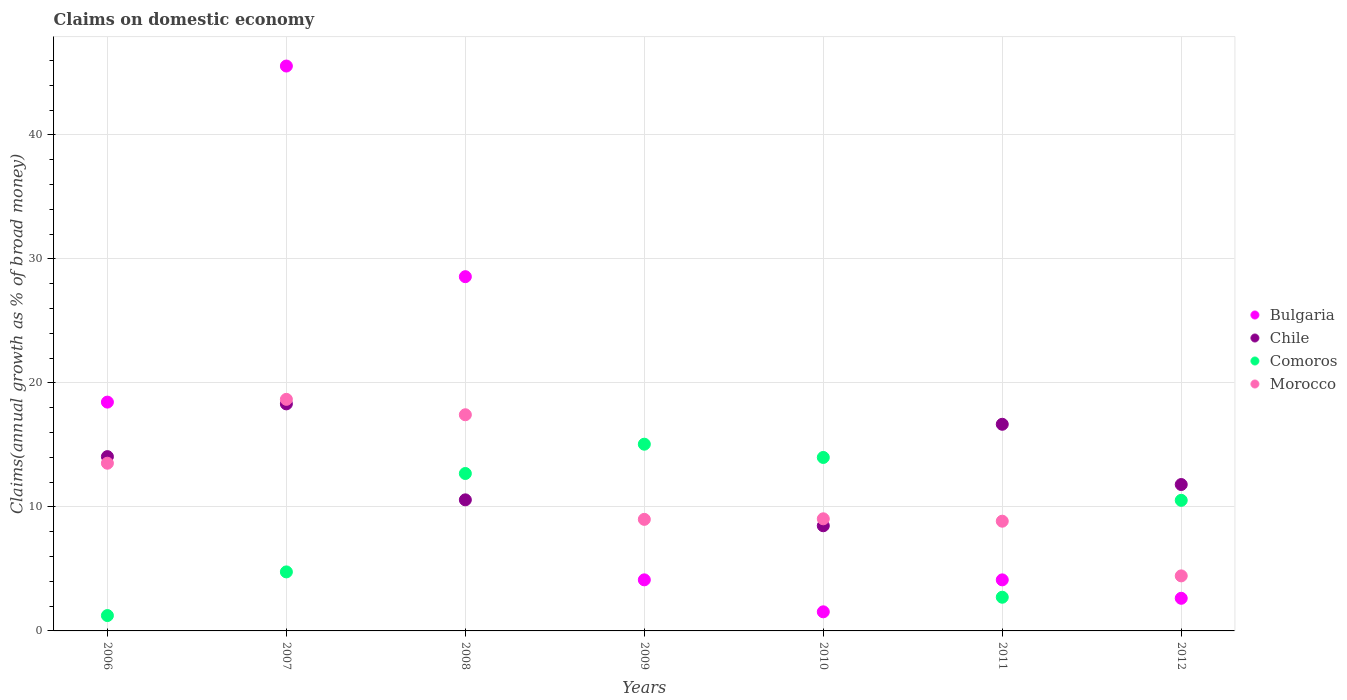How many different coloured dotlines are there?
Offer a very short reply. 4. What is the percentage of broad money claimed on domestic economy in Chile in 2009?
Ensure brevity in your answer.  0. Across all years, what is the maximum percentage of broad money claimed on domestic economy in Chile?
Keep it short and to the point. 18.31. Across all years, what is the minimum percentage of broad money claimed on domestic economy in Morocco?
Give a very brief answer. 4.44. In which year was the percentage of broad money claimed on domestic economy in Comoros maximum?
Your response must be concise. 2009. What is the total percentage of broad money claimed on domestic economy in Comoros in the graph?
Provide a succinct answer. 61. What is the difference between the percentage of broad money claimed on domestic economy in Morocco in 2007 and that in 2012?
Give a very brief answer. 14.24. What is the difference between the percentage of broad money claimed on domestic economy in Bulgaria in 2011 and the percentage of broad money claimed on domestic economy in Morocco in 2007?
Provide a short and direct response. -14.56. What is the average percentage of broad money claimed on domestic economy in Comoros per year?
Ensure brevity in your answer.  8.71. In the year 2006, what is the difference between the percentage of broad money claimed on domestic economy in Morocco and percentage of broad money claimed on domestic economy in Comoros?
Keep it short and to the point. 12.29. In how many years, is the percentage of broad money claimed on domestic economy in Chile greater than 14 %?
Provide a short and direct response. 3. What is the ratio of the percentage of broad money claimed on domestic economy in Bulgaria in 2009 to that in 2012?
Ensure brevity in your answer.  1.57. Is the percentage of broad money claimed on domestic economy in Bulgaria in 2009 less than that in 2012?
Offer a very short reply. No. What is the difference between the highest and the second highest percentage of broad money claimed on domestic economy in Bulgaria?
Provide a succinct answer. 16.99. What is the difference between the highest and the lowest percentage of broad money claimed on domestic economy in Morocco?
Provide a short and direct response. 14.24. In how many years, is the percentage of broad money claimed on domestic economy in Chile greater than the average percentage of broad money claimed on domestic economy in Chile taken over all years?
Your response must be concise. 4. Is it the case that in every year, the sum of the percentage of broad money claimed on domestic economy in Bulgaria and percentage of broad money claimed on domestic economy in Morocco  is greater than the percentage of broad money claimed on domestic economy in Comoros?
Ensure brevity in your answer.  No. Is the percentage of broad money claimed on domestic economy in Chile strictly greater than the percentage of broad money claimed on domestic economy in Comoros over the years?
Offer a very short reply. No. Is the percentage of broad money claimed on domestic economy in Comoros strictly less than the percentage of broad money claimed on domestic economy in Bulgaria over the years?
Your response must be concise. No. How many dotlines are there?
Your answer should be compact. 4. How many years are there in the graph?
Offer a terse response. 7. What is the difference between two consecutive major ticks on the Y-axis?
Keep it short and to the point. 10. Are the values on the major ticks of Y-axis written in scientific E-notation?
Provide a succinct answer. No. Where does the legend appear in the graph?
Keep it short and to the point. Center right. How are the legend labels stacked?
Your answer should be compact. Vertical. What is the title of the graph?
Give a very brief answer. Claims on domestic economy. Does "Madagascar" appear as one of the legend labels in the graph?
Offer a terse response. No. What is the label or title of the Y-axis?
Offer a terse response. Claims(annual growth as % of broad money). What is the Claims(annual growth as % of broad money) in Bulgaria in 2006?
Your answer should be very brief. 18.45. What is the Claims(annual growth as % of broad money) in Chile in 2006?
Provide a short and direct response. 14.06. What is the Claims(annual growth as % of broad money) of Comoros in 2006?
Your answer should be compact. 1.24. What is the Claims(annual growth as % of broad money) of Morocco in 2006?
Ensure brevity in your answer.  13.53. What is the Claims(annual growth as % of broad money) in Bulgaria in 2007?
Provide a succinct answer. 45.56. What is the Claims(annual growth as % of broad money) in Chile in 2007?
Ensure brevity in your answer.  18.31. What is the Claims(annual growth as % of broad money) of Comoros in 2007?
Keep it short and to the point. 4.76. What is the Claims(annual growth as % of broad money) in Morocco in 2007?
Offer a terse response. 18.68. What is the Claims(annual growth as % of broad money) in Bulgaria in 2008?
Give a very brief answer. 28.57. What is the Claims(annual growth as % of broad money) of Chile in 2008?
Offer a terse response. 10.57. What is the Claims(annual growth as % of broad money) in Comoros in 2008?
Give a very brief answer. 12.7. What is the Claims(annual growth as % of broad money) in Morocco in 2008?
Your response must be concise. 17.43. What is the Claims(annual growth as % of broad money) in Bulgaria in 2009?
Ensure brevity in your answer.  4.12. What is the Claims(annual growth as % of broad money) of Chile in 2009?
Make the answer very short. 0. What is the Claims(annual growth as % of broad money) of Comoros in 2009?
Your response must be concise. 15.06. What is the Claims(annual growth as % of broad money) of Morocco in 2009?
Make the answer very short. 9. What is the Claims(annual growth as % of broad money) of Bulgaria in 2010?
Give a very brief answer. 1.54. What is the Claims(annual growth as % of broad money) of Chile in 2010?
Keep it short and to the point. 8.48. What is the Claims(annual growth as % of broad money) in Comoros in 2010?
Ensure brevity in your answer.  13.99. What is the Claims(annual growth as % of broad money) in Morocco in 2010?
Give a very brief answer. 9.04. What is the Claims(annual growth as % of broad money) in Bulgaria in 2011?
Provide a short and direct response. 4.12. What is the Claims(annual growth as % of broad money) of Chile in 2011?
Make the answer very short. 16.67. What is the Claims(annual growth as % of broad money) in Comoros in 2011?
Keep it short and to the point. 2.72. What is the Claims(annual growth as % of broad money) in Morocco in 2011?
Provide a short and direct response. 8.85. What is the Claims(annual growth as % of broad money) in Bulgaria in 2012?
Your answer should be compact. 2.63. What is the Claims(annual growth as % of broad money) of Chile in 2012?
Provide a succinct answer. 11.81. What is the Claims(annual growth as % of broad money) in Comoros in 2012?
Offer a very short reply. 10.53. What is the Claims(annual growth as % of broad money) in Morocco in 2012?
Your answer should be very brief. 4.44. Across all years, what is the maximum Claims(annual growth as % of broad money) of Bulgaria?
Your answer should be very brief. 45.56. Across all years, what is the maximum Claims(annual growth as % of broad money) in Chile?
Provide a short and direct response. 18.31. Across all years, what is the maximum Claims(annual growth as % of broad money) of Comoros?
Your answer should be compact. 15.06. Across all years, what is the maximum Claims(annual growth as % of broad money) of Morocco?
Your answer should be compact. 18.68. Across all years, what is the minimum Claims(annual growth as % of broad money) of Bulgaria?
Ensure brevity in your answer.  1.54. Across all years, what is the minimum Claims(annual growth as % of broad money) of Chile?
Your answer should be very brief. 0. Across all years, what is the minimum Claims(annual growth as % of broad money) of Comoros?
Make the answer very short. 1.24. Across all years, what is the minimum Claims(annual growth as % of broad money) in Morocco?
Give a very brief answer. 4.44. What is the total Claims(annual growth as % of broad money) of Bulgaria in the graph?
Offer a very short reply. 104.99. What is the total Claims(annual growth as % of broad money) of Chile in the graph?
Ensure brevity in your answer.  79.9. What is the total Claims(annual growth as % of broad money) in Comoros in the graph?
Make the answer very short. 61. What is the total Claims(annual growth as % of broad money) in Morocco in the graph?
Offer a terse response. 80.97. What is the difference between the Claims(annual growth as % of broad money) in Bulgaria in 2006 and that in 2007?
Your response must be concise. -27.11. What is the difference between the Claims(annual growth as % of broad money) in Chile in 2006 and that in 2007?
Provide a succinct answer. -4.25. What is the difference between the Claims(annual growth as % of broad money) of Comoros in 2006 and that in 2007?
Your answer should be compact. -3.52. What is the difference between the Claims(annual growth as % of broad money) of Morocco in 2006 and that in 2007?
Offer a very short reply. -5.15. What is the difference between the Claims(annual growth as % of broad money) in Bulgaria in 2006 and that in 2008?
Keep it short and to the point. -10.12. What is the difference between the Claims(annual growth as % of broad money) in Chile in 2006 and that in 2008?
Your answer should be very brief. 3.49. What is the difference between the Claims(annual growth as % of broad money) in Comoros in 2006 and that in 2008?
Offer a very short reply. -11.46. What is the difference between the Claims(annual growth as % of broad money) of Morocco in 2006 and that in 2008?
Provide a succinct answer. -3.91. What is the difference between the Claims(annual growth as % of broad money) in Bulgaria in 2006 and that in 2009?
Keep it short and to the point. 14.33. What is the difference between the Claims(annual growth as % of broad money) of Comoros in 2006 and that in 2009?
Provide a short and direct response. -13.82. What is the difference between the Claims(annual growth as % of broad money) in Morocco in 2006 and that in 2009?
Keep it short and to the point. 4.53. What is the difference between the Claims(annual growth as % of broad money) in Bulgaria in 2006 and that in 2010?
Give a very brief answer. 16.91. What is the difference between the Claims(annual growth as % of broad money) of Chile in 2006 and that in 2010?
Your response must be concise. 5.58. What is the difference between the Claims(annual growth as % of broad money) of Comoros in 2006 and that in 2010?
Give a very brief answer. -12.75. What is the difference between the Claims(annual growth as % of broad money) in Morocco in 2006 and that in 2010?
Provide a short and direct response. 4.48. What is the difference between the Claims(annual growth as % of broad money) of Bulgaria in 2006 and that in 2011?
Your response must be concise. 14.34. What is the difference between the Claims(annual growth as % of broad money) in Chile in 2006 and that in 2011?
Make the answer very short. -2.61. What is the difference between the Claims(annual growth as % of broad money) in Comoros in 2006 and that in 2011?
Your response must be concise. -1.48. What is the difference between the Claims(annual growth as % of broad money) of Morocco in 2006 and that in 2011?
Your answer should be compact. 4.68. What is the difference between the Claims(annual growth as % of broad money) of Bulgaria in 2006 and that in 2012?
Your answer should be compact. 15.82. What is the difference between the Claims(annual growth as % of broad money) of Chile in 2006 and that in 2012?
Your answer should be compact. 2.25. What is the difference between the Claims(annual growth as % of broad money) in Comoros in 2006 and that in 2012?
Offer a terse response. -9.29. What is the difference between the Claims(annual growth as % of broad money) of Morocco in 2006 and that in 2012?
Offer a terse response. 9.09. What is the difference between the Claims(annual growth as % of broad money) of Bulgaria in 2007 and that in 2008?
Provide a short and direct response. 16.99. What is the difference between the Claims(annual growth as % of broad money) of Chile in 2007 and that in 2008?
Provide a succinct answer. 7.74. What is the difference between the Claims(annual growth as % of broad money) in Comoros in 2007 and that in 2008?
Make the answer very short. -7.94. What is the difference between the Claims(annual growth as % of broad money) in Morocco in 2007 and that in 2008?
Your answer should be compact. 1.24. What is the difference between the Claims(annual growth as % of broad money) in Bulgaria in 2007 and that in 2009?
Make the answer very short. 41.44. What is the difference between the Claims(annual growth as % of broad money) in Comoros in 2007 and that in 2009?
Your answer should be very brief. -10.3. What is the difference between the Claims(annual growth as % of broad money) of Morocco in 2007 and that in 2009?
Keep it short and to the point. 9.68. What is the difference between the Claims(annual growth as % of broad money) of Bulgaria in 2007 and that in 2010?
Provide a succinct answer. 44.02. What is the difference between the Claims(annual growth as % of broad money) in Chile in 2007 and that in 2010?
Provide a short and direct response. 9.83. What is the difference between the Claims(annual growth as % of broad money) of Comoros in 2007 and that in 2010?
Provide a succinct answer. -9.23. What is the difference between the Claims(annual growth as % of broad money) of Morocco in 2007 and that in 2010?
Provide a short and direct response. 9.63. What is the difference between the Claims(annual growth as % of broad money) in Bulgaria in 2007 and that in 2011?
Offer a terse response. 41.44. What is the difference between the Claims(annual growth as % of broad money) in Chile in 2007 and that in 2011?
Give a very brief answer. 1.65. What is the difference between the Claims(annual growth as % of broad money) of Comoros in 2007 and that in 2011?
Provide a short and direct response. 2.04. What is the difference between the Claims(annual growth as % of broad money) in Morocco in 2007 and that in 2011?
Provide a short and direct response. 9.83. What is the difference between the Claims(annual growth as % of broad money) of Bulgaria in 2007 and that in 2012?
Offer a terse response. 42.93. What is the difference between the Claims(annual growth as % of broad money) in Chile in 2007 and that in 2012?
Ensure brevity in your answer.  6.5. What is the difference between the Claims(annual growth as % of broad money) of Comoros in 2007 and that in 2012?
Provide a short and direct response. -5.77. What is the difference between the Claims(annual growth as % of broad money) in Morocco in 2007 and that in 2012?
Offer a terse response. 14.24. What is the difference between the Claims(annual growth as % of broad money) in Bulgaria in 2008 and that in 2009?
Offer a terse response. 24.45. What is the difference between the Claims(annual growth as % of broad money) in Comoros in 2008 and that in 2009?
Provide a succinct answer. -2.36. What is the difference between the Claims(annual growth as % of broad money) of Morocco in 2008 and that in 2009?
Make the answer very short. 8.44. What is the difference between the Claims(annual growth as % of broad money) in Bulgaria in 2008 and that in 2010?
Ensure brevity in your answer.  27.03. What is the difference between the Claims(annual growth as % of broad money) in Chile in 2008 and that in 2010?
Provide a succinct answer. 2.09. What is the difference between the Claims(annual growth as % of broad money) of Comoros in 2008 and that in 2010?
Give a very brief answer. -1.29. What is the difference between the Claims(annual growth as % of broad money) of Morocco in 2008 and that in 2010?
Keep it short and to the point. 8.39. What is the difference between the Claims(annual growth as % of broad money) in Bulgaria in 2008 and that in 2011?
Your response must be concise. 24.45. What is the difference between the Claims(annual growth as % of broad money) in Chile in 2008 and that in 2011?
Your response must be concise. -6.09. What is the difference between the Claims(annual growth as % of broad money) of Comoros in 2008 and that in 2011?
Offer a terse response. 9.98. What is the difference between the Claims(annual growth as % of broad money) of Morocco in 2008 and that in 2011?
Offer a very short reply. 8.58. What is the difference between the Claims(annual growth as % of broad money) of Bulgaria in 2008 and that in 2012?
Offer a very short reply. 25.94. What is the difference between the Claims(annual growth as % of broad money) in Chile in 2008 and that in 2012?
Provide a short and direct response. -1.24. What is the difference between the Claims(annual growth as % of broad money) of Comoros in 2008 and that in 2012?
Your answer should be very brief. 2.16. What is the difference between the Claims(annual growth as % of broad money) of Morocco in 2008 and that in 2012?
Your answer should be very brief. 12.99. What is the difference between the Claims(annual growth as % of broad money) of Bulgaria in 2009 and that in 2010?
Provide a short and direct response. 2.58. What is the difference between the Claims(annual growth as % of broad money) in Comoros in 2009 and that in 2010?
Ensure brevity in your answer.  1.07. What is the difference between the Claims(annual growth as % of broad money) of Morocco in 2009 and that in 2010?
Make the answer very short. -0.04. What is the difference between the Claims(annual growth as % of broad money) in Bulgaria in 2009 and that in 2011?
Give a very brief answer. 0. What is the difference between the Claims(annual growth as % of broad money) in Comoros in 2009 and that in 2011?
Give a very brief answer. 12.34. What is the difference between the Claims(annual growth as % of broad money) of Morocco in 2009 and that in 2011?
Give a very brief answer. 0.15. What is the difference between the Claims(annual growth as % of broad money) in Bulgaria in 2009 and that in 2012?
Give a very brief answer. 1.49. What is the difference between the Claims(annual growth as % of broad money) in Comoros in 2009 and that in 2012?
Provide a short and direct response. 4.53. What is the difference between the Claims(annual growth as % of broad money) of Morocco in 2009 and that in 2012?
Make the answer very short. 4.56. What is the difference between the Claims(annual growth as % of broad money) in Bulgaria in 2010 and that in 2011?
Provide a short and direct response. -2.58. What is the difference between the Claims(annual growth as % of broad money) in Chile in 2010 and that in 2011?
Your response must be concise. -8.19. What is the difference between the Claims(annual growth as % of broad money) of Comoros in 2010 and that in 2011?
Offer a terse response. 11.27. What is the difference between the Claims(annual growth as % of broad money) of Morocco in 2010 and that in 2011?
Your answer should be very brief. 0.19. What is the difference between the Claims(annual growth as % of broad money) of Bulgaria in 2010 and that in 2012?
Your answer should be very brief. -1.09. What is the difference between the Claims(annual growth as % of broad money) in Chile in 2010 and that in 2012?
Keep it short and to the point. -3.33. What is the difference between the Claims(annual growth as % of broad money) in Comoros in 2010 and that in 2012?
Offer a terse response. 3.46. What is the difference between the Claims(annual growth as % of broad money) in Morocco in 2010 and that in 2012?
Your answer should be compact. 4.6. What is the difference between the Claims(annual growth as % of broad money) of Bulgaria in 2011 and that in 2012?
Offer a very short reply. 1.49. What is the difference between the Claims(annual growth as % of broad money) of Chile in 2011 and that in 2012?
Offer a very short reply. 4.86. What is the difference between the Claims(annual growth as % of broad money) in Comoros in 2011 and that in 2012?
Provide a succinct answer. -7.81. What is the difference between the Claims(annual growth as % of broad money) of Morocco in 2011 and that in 2012?
Give a very brief answer. 4.41. What is the difference between the Claims(annual growth as % of broad money) of Bulgaria in 2006 and the Claims(annual growth as % of broad money) of Chile in 2007?
Your answer should be compact. 0.14. What is the difference between the Claims(annual growth as % of broad money) of Bulgaria in 2006 and the Claims(annual growth as % of broad money) of Comoros in 2007?
Offer a terse response. 13.69. What is the difference between the Claims(annual growth as % of broad money) in Bulgaria in 2006 and the Claims(annual growth as % of broad money) in Morocco in 2007?
Provide a short and direct response. -0.22. What is the difference between the Claims(annual growth as % of broad money) of Chile in 2006 and the Claims(annual growth as % of broad money) of Comoros in 2007?
Provide a succinct answer. 9.3. What is the difference between the Claims(annual growth as % of broad money) in Chile in 2006 and the Claims(annual growth as % of broad money) in Morocco in 2007?
Offer a very short reply. -4.62. What is the difference between the Claims(annual growth as % of broad money) of Comoros in 2006 and the Claims(annual growth as % of broad money) of Morocco in 2007?
Your response must be concise. -17.44. What is the difference between the Claims(annual growth as % of broad money) of Bulgaria in 2006 and the Claims(annual growth as % of broad money) of Chile in 2008?
Offer a very short reply. 7.88. What is the difference between the Claims(annual growth as % of broad money) of Bulgaria in 2006 and the Claims(annual growth as % of broad money) of Comoros in 2008?
Offer a very short reply. 5.76. What is the difference between the Claims(annual growth as % of broad money) in Bulgaria in 2006 and the Claims(annual growth as % of broad money) in Morocco in 2008?
Your response must be concise. 1.02. What is the difference between the Claims(annual growth as % of broad money) of Chile in 2006 and the Claims(annual growth as % of broad money) of Comoros in 2008?
Your answer should be compact. 1.36. What is the difference between the Claims(annual growth as % of broad money) in Chile in 2006 and the Claims(annual growth as % of broad money) in Morocco in 2008?
Give a very brief answer. -3.38. What is the difference between the Claims(annual growth as % of broad money) in Comoros in 2006 and the Claims(annual growth as % of broad money) in Morocco in 2008?
Offer a terse response. -16.19. What is the difference between the Claims(annual growth as % of broad money) of Bulgaria in 2006 and the Claims(annual growth as % of broad money) of Comoros in 2009?
Your answer should be compact. 3.39. What is the difference between the Claims(annual growth as % of broad money) in Bulgaria in 2006 and the Claims(annual growth as % of broad money) in Morocco in 2009?
Ensure brevity in your answer.  9.46. What is the difference between the Claims(annual growth as % of broad money) of Chile in 2006 and the Claims(annual growth as % of broad money) of Comoros in 2009?
Provide a short and direct response. -1. What is the difference between the Claims(annual growth as % of broad money) of Chile in 2006 and the Claims(annual growth as % of broad money) of Morocco in 2009?
Your response must be concise. 5.06. What is the difference between the Claims(annual growth as % of broad money) of Comoros in 2006 and the Claims(annual growth as % of broad money) of Morocco in 2009?
Ensure brevity in your answer.  -7.76. What is the difference between the Claims(annual growth as % of broad money) of Bulgaria in 2006 and the Claims(annual growth as % of broad money) of Chile in 2010?
Provide a succinct answer. 9.97. What is the difference between the Claims(annual growth as % of broad money) in Bulgaria in 2006 and the Claims(annual growth as % of broad money) in Comoros in 2010?
Provide a succinct answer. 4.46. What is the difference between the Claims(annual growth as % of broad money) of Bulgaria in 2006 and the Claims(annual growth as % of broad money) of Morocco in 2010?
Offer a terse response. 9.41. What is the difference between the Claims(annual growth as % of broad money) of Chile in 2006 and the Claims(annual growth as % of broad money) of Comoros in 2010?
Your response must be concise. 0.07. What is the difference between the Claims(annual growth as % of broad money) of Chile in 2006 and the Claims(annual growth as % of broad money) of Morocco in 2010?
Provide a short and direct response. 5.01. What is the difference between the Claims(annual growth as % of broad money) of Comoros in 2006 and the Claims(annual growth as % of broad money) of Morocco in 2010?
Offer a very short reply. -7.8. What is the difference between the Claims(annual growth as % of broad money) of Bulgaria in 2006 and the Claims(annual growth as % of broad money) of Chile in 2011?
Your answer should be very brief. 1.79. What is the difference between the Claims(annual growth as % of broad money) in Bulgaria in 2006 and the Claims(annual growth as % of broad money) in Comoros in 2011?
Offer a very short reply. 15.74. What is the difference between the Claims(annual growth as % of broad money) of Bulgaria in 2006 and the Claims(annual growth as % of broad money) of Morocco in 2011?
Your answer should be compact. 9.6. What is the difference between the Claims(annual growth as % of broad money) in Chile in 2006 and the Claims(annual growth as % of broad money) in Comoros in 2011?
Your answer should be very brief. 11.34. What is the difference between the Claims(annual growth as % of broad money) in Chile in 2006 and the Claims(annual growth as % of broad money) in Morocco in 2011?
Provide a short and direct response. 5.21. What is the difference between the Claims(annual growth as % of broad money) of Comoros in 2006 and the Claims(annual growth as % of broad money) of Morocco in 2011?
Keep it short and to the point. -7.61. What is the difference between the Claims(annual growth as % of broad money) of Bulgaria in 2006 and the Claims(annual growth as % of broad money) of Chile in 2012?
Provide a succinct answer. 6.65. What is the difference between the Claims(annual growth as % of broad money) in Bulgaria in 2006 and the Claims(annual growth as % of broad money) in Comoros in 2012?
Keep it short and to the point. 7.92. What is the difference between the Claims(annual growth as % of broad money) in Bulgaria in 2006 and the Claims(annual growth as % of broad money) in Morocco in 2012?
Offer a terse response. 14.02. What is the difference between the Claims(annual growth as % of broad money) in Chile in 2006 and the Claims(annual growth as % of broad money) in Comoros in 2012?
Make the answer very short. 3.53. What is the difference between the Claims(annual growth as % of broad money) of Chile in 2006 and the Claims(annual growth as % of broad money) of Morocco in 2012?
Your answer should be compact. 9.62. What is the difference between the Claims(annual growth as % of broad money) in Comoros in 2006 and the Claims(annual growth as % of broad money) in Morocco in 2012?
Ensure brevity in your answer.  -3.2. What is the difference between the Claims(annual growth as % of broad money) of Bulgaria in 2007 and the Claims(annual growth as % of broad money) of Chile in 2008?
Your response must be concise. 34.99. What is the difference between the Claims(annual growth as % of broad money) of Bulgaria in 2007 and the Claims(annual growth as % of broad money) of Comoros in 2008?
Give a very brief answer. 32.86. What is the difference between the Claims(annual growth as % of broad money) of Bulgaria in 2007 and the Claims(annual growth as % of broad money) of Morocco in 2008?
Make the answer very short. 28.13. What is the difference between the Claims(annual growth as % of broad money) in Chile in 2007 and the Claims(annual growth as % of broad money) in Comoros in 2008?
Offer a terse response. 5.62. What is the difference between the Claims(annual growth as % of broad money) in Chile in 2007 and the Claims(annual growth as % of broad money) in Morocco in 2008?
Your answer should be compact. 0.88. What is the difference between the Claims(annual growth as % of broad money) in Comoros in 2007 and the Claims(annual growth as % of broad money) in Morocco in 2008?
Give a very brief answer. -12.67. What is the difference between the Claims(annual growth as % of broad money) of Bulgaria in 2007 and the Claims(annual growth as % of broad money) of Comoros in 2009?
Provide a succinct answer. 30.5. What is the difference between the Claims(annual growth as % of broad money) of Bulgaria in 2007 and the Claims(annual growth as % of broad money) of Morocco in 2009?
Keep it short and to the point. 36.56. What is the difference between the Claims(annual growth as % of broad money) of Chile in 2007 and the Claims(annual growth as % of broad money) of Comoros in 2009?
Offer a very short reply. 3.25. What is the difference between the Claims(annual growth as % of broad money) of Chile in 2007 and the Claims(annual growth as % of broad money) of Morocco in 2009?
Ensure brevity in your answer.  9.31. What is the difference between the Claims(annual growth as % of broad money) of Comoros in 2007 and the Claims(annual growth as % of broad money) of Morocco in 2009?
Make the answer very short. -4.24. What is the difference between the Claims(annual growth as % of broad money) of Bulgaria in 2007 and the Claims(annual growth as % of broad money) of Chile in 2010?
Provide a succinct answer. 37.08. What is the difference between the Claims(annual growth as % of broad money) in Bulgaria in 2007 and the Claims(annual growth as % of broad money) in Comoros in 2010?
Provide a short and direct response. 31.57. What is the difference between the Claims(annual growth as % of broad money) of Bulgaria in 2007 and the Claims(annual growth as % of broad money) of Morocco in 2010?
Your response must be concise. 36.52. What is the difference between the Claims(annual growth as % of broad money) in Chile in 2007 and the Claims(annual growth as % of broad money) in Comoros in 2010?
Offer a very short reply. 4.32. What is the difference between the Claims(annual growth as % of broad money) in Chile in 2007 and the Claims(annual growth as % of broad money) in Morocco in 2010?
Provide a short and direct response. 9.27. What is the difference between the Claims(annual growth as % of broad money) in Comoros in 2007 and the Claims(annual growth as % of broad money) in Morocco in 2010?
Give a very brief answer. -4.28. What is the difference between the Claims(annual growth as % of broad money) of Bulgaria in 2007 and the Claims(annual growth as % of broad money) of Chile in 2011?
Make the answer very short. 28.89. What is the difference between the Claims(annual growth as % of broad money) in Bulgaria in 2007 and the Claims(annual growth as % of broad money) in Comoros in 2011?
Ensure brevity in your answer.  42.84. What is the difference between the Claims(annual growth as % of broad money) of Bulgaria in 2007 and the Claims(annual growth as % of broad money) of Morocco in 2011?
Keep it short and to the point. 36.71. What is the difference between the Claims(annual growth as % of broad money) of Chile in 2007 and the Claims(annual growth as % of broad money) of Comoros in 2011?
Give a very brief answer. 15.59. What is the difference between the Claims(annual growth as % of broad money) of Chile in 2007 and the Claims(annual growth as % of broad money) of Morocco in 2011?
Offer a very short reply. 9.46. What is the difference between the Claims(annual growth as % of broad money) in Comoros in 2007 and the Claims(annual growth as % of broad money) in Morocco in 2011?
Offer a terse response. -4.09. What is the difference between the Claims(annual growth as % of broad money) in Bulgaria in 2007 and the Claims(annual growth as % of broad money) in Chile in 2012?
Your answer should be compact. 33.75. What is the difference between the Claims(annual growth as % of broad money) in Bulgaria in 2007 and the Claims(annual growth as % of broad money) in Comoros in 2012?
Provide a succinct answer. 35.03. What is the difference between the Claims(annual growth as % of broad money) of Bulgaria in 2007 and the Claims(annual growth as % of broad money) of Morocco in 2012?
Offer a terse response. 41.12. What is the difference between the Claims(annual growth as % of broad money) of Chile in 2007 and the Claims(annual growth as % of broad money) of Comoros in 2012?
Your answer should be very brief. 7.78. What is the difference between the Claims(annual growth as % of broad money) of Chile in 2007 and the Claims(annual growth as % of broad money) of Morocco in 2012?
Give a very brief answer. 13.87. What is the difference between the Claims(annual growth as % of broad money) of Comoros in 2007 and the Claims(annual growth as % of broad money) of Morocco in 2012?
Provide a succinct answer. 0.32. What is the difference between the Claims(annual growth as % of broad money) in Bulgaria in 2008 and the Claims(annual growth as % of broad money) in Comoros in 2009?
Give a very brief answer. 13.51. What is the difference between the Claims(annual growth as % of broad money) in Bulgaria in 2008 and the Claims(annual growth as % of broad money) in Morocco in 2009?
Your answer should be very brief. 19.57. What is the difference between the Claims(annual growth as % of broad money) of Chile in 2008 and the Claims(annual growth as % of broad money) of Comoros in 2009?
Your response must be concise. -4.49. What is the difference between the Claims(annual growth as % of broad money) of Chile in 2008 and the Claims(annual growth as % of broad money) of Morocco in 2009?
Give a very brief answer. 1.57. What is the difference between the Claims(annual growth as % of broad money) of Comoros in 2008 and the Claims(annual growth as % of broad money) of Morocco in 2009?
Give a very brief answer. 3.7. What is the difference between the Claims(annual growth as % of broad money) in Bulgaria in 2008 and the Claims(annual growth as % of broad money) in Chile in 2010?
Ensure brevity in your answer.  20.09. What is the difference between the Claims(annual growth as % of broad money) in Bulgaria in 2008 and the Claims(annual growth as % of broad money) in Comoros in 2010?
Provide a short and direct response. 14.58. What is the difference between the Claims(annual growth as % of broad money) in Bulgaria in 2008 and the Claims(annual growth as % of broad money) in Morocco in 2010?
Your answer should be compact. 19.53. What is the difference between the Claims(annual growth as % of broad money) of Chile in 2008 and the Claims(annual growth as % of broad money) of Comoros in 2010?
Your answer should be compact. -3.42. What is the difference between the Claims(annual growth as % of broad money) in Chile in 2008 and the Claims(annual growth as % of broad money) in Morocco in 2010?
Your answer should be very brief. 1.53. What is the difference between the Claims(annual growth as % of broad money) of Comoros in 2008 and the Claims(annual growth as % of broad money) of Morocco in 2010?
Give a very brief answer. 3.65. What is the difference between the Claims(annual growth as % of broad money) in Bulgaria in 2008 and the Claims(annual growth as % of broad money) in Chile in 2011?
Offer a very short reply. 11.9. What is the difference between the Claims(annual growth as % of broad money) of Bulgaria in 2008 and the Claims(annual growth as % of broad money) of Comoros in 2011?
Make the answer very short. 25.85. What is the difference between the Claims(annual growth as % of broad money) of Bulgaria in 2008 and the Claims(annual growth as % of broad money) of Morocco in 2011?
Offer a terse response. 19.72. What is the difference between the Claims(annual growth as % of broad money) in Chile in 2008 and the Claims(annual growth as % of broad money) in Comoros in 2011?
Ensure brevity in your answer.  7.85. What is the difference between the Claims(annual growth as % of broad money) in Chile in 2008 and the Claims(annual growth as % of broad money) in Morocco in 2011?
Keep it short and to the point. 1.72. What is the difference between the Claims(annual growth as % of broad money) in Comoros in 2008 and the Claims(annual growth as % of broad money) in Morocco in 2011?
Your answer should be compact. 3.85. What is the difference between the Claims(annual growth as % of broad money) in Bulgaria in 2008 and the Claims(annual growth as % of broad money) in Chile in 2012?
Ensure brevity in your answer.  16.76. What is the difference between the Claims(annual growth as % of broad money) of Bulgaria in 2008 and the Claims(annual growth as % of broad money) of Comoros in 2012?
Ensure brevity in your answer.  18.04. What is the difference between the Claims(annual growth as % of broad money) of Bulgaria in 2008 and the Claims(annual growth as % of broad money) of Morocco in 2012?
Your answer should be compact. 24.13. What is the difference between the Claims(annual growth as % of broad money) of Chile in 2008 and the Claims(annual growth as % of broad money) of Comoros in 2012?
Provide a succinct answer. 0.04. What is the difference between the Claims(annual growth as % of broad money) of Chile in 2008 and the Claims(annual growth as % of broad money) of Morocco in 2012?
Your response must be concise. 6.13. What is the difference between the Claims(annual growth as % of broad money) of Comoros in 2008 and the Claims(annual growth as % of broad money) of Morocco in 2012?
Your answer should be compact. 8.26. What is the difference between the Claims(annual growth as % of broad money) of Bulgaria in 2009 and the Claims(annual growth as % of broad money) of Chile in 2010?
Make the answer very short. -4.36. What is the difference between the Claims(annual growth as % of broad money) of Bulgaria in 2009 and the Claims(annual growth as % of broad money) of Comoros in 2010?
Ensure brevity in your answer.  -9.87. What is the difference between the Claims(annual growth as % of broad money) in Bulgaria in 2009 and the Claims(annual growth as % of broad money) in Morocco in 2010?
Make the answer very short. -4.92. What is the difference between the Claims(annual growth as % of broad money) in Comoros in 2009 and the Claims(annual growth as % of broad money) in Morocco in 2010?
Your response must be concise. 6.02. What is the difference between the Claims(annual growth as % of broad money) of Bulgaria in 2009 and the Claims(annual growth as % of broad money) of Chile in 2011?
Your answer should be very brief. -12.55. What is the difference between the Claims(annual growth as % of broad money) of Bulgaria in 2009 and the Claims(annual growth as % of broad money) of Comoros in 2011?
Provide a short and direct response. 1.4. What is the difference between the Claims(annual growth as % of broad money) of Bulgaria in 2009 and the Claims(annual growth as % of broad money) of Morocco in 2011?
Offer a very short reply. -4.73. What is the difference between the Claims(annual growth as % of broad money) in Comoros in 2009 and the Claims(annual growth as % of broad money) in Morocco in 2011?
Keep it short and to the point. 6.21. What is the difference between the Claims(annual growth as % of broad money) of Bulgaria in 2009 and the Claims(annual growth as % of broad money) of Chile in 2012?
Your answer should be very brief. -7.69. What is the difference between the Claims(annual growth as % of broad money) in Bulgaria in 2009 and the Claims(annual growth as % of broad money) in Comoros in 2012?
Give a very brief answer. -6.41. What is the difference between the Claims(annual growth as % of broad money) of Bulgaria in 2009 and the Claims(annual growth as % of broad money) of Morocco in 2012?
Offer a terse response. -0.32. What is the difference between the Claims(annual growth as % of broad money) of Comoros in 2009 and the Claims(annual growth as % of broad money) of Morocco in 2012?
Ensure brevity in your answer.  10.62. What is the difference between the Claims(annual growth as % of broad money) of Bulgaria in 2010 and the Claims(annual growth as % of broad money) of Chile in 2011?
Make the answer very short. -15.13. What is the difference between the Claims(annual growth as % of broad money) of Bulgaria in 2010 and the Claims(annual growth as % of broad money) of Comoros in 2011?
Your answer should be very brief. -1.18. What is the difference between the Claims(annual growth as % of broad money) of Bulgaria in 2010 and the Claims(annual growth as % of broad money) of Morocco in 2011?
Your answer should be very brief. -7.31. What is the difference between the Claims(annual growth as % of broad money) in Chile in 2010 and the Claims(annual growth as % of broad money) in Comoros in 2011?
Ensure brevity in your answer.  5.76. What is the difference between the Claims(annual growth as % of broad money) in Chile in 2010 and the Claims(annual growth as % of broad money) in Morocco in 2011?
Provide a succinct answer. -0.37. What is the difference between the Claims(annual growth as % of broad money) of Comoros in 2010 and the Claims(annual growth as % of broad money) of Morocco in 2011?
Offer a very short reply. 5.14. What is the difference between the Claims(annual growth as % of broad money) of Bulgaria in 2010 and the Claims(annual growth as % of broad money) of Chile in 2012?
Ensure brevity in your answer.  -10.27. What is the difference between the Claims(annual growth as % of broad money) in Bulgaria in 2010 and the Claims(annual growth as % of broad money) in Comoros in 2012?
Make the answer very short. -8.99. What is the difference between the Claims(annual growth as % of broad money) of Bulgaria in 2010 and the Claims(annual growth as % of broad money) of Morocco in 2012?
Offer a terse response. -2.9. What is the difference between the Claims(annual growth as % of broad money) in Chile in 2010 and the Claims(annual growth as % of broad money) in Comoros in 2012?
Provide a succinct answer. -2.05. What is the difference between the Claims(annual growth as % of broad money) in Chile in 2010 and the Claims(annual growth as % of broad money) in Morocco in 2012?
Keep it short and to the point. 4.04. What is the difference between the Claims(annual growth as % of broad money) of Comoros in 2010 and the Claims(annual growth as % of broad money) of Morocco in 2012?
Provide a short and direct response. 9.55. What is the difference between the Claims(annual growth as % of broad money) in Bulgaria in 2011 and the Claims(annual growth as % of broad money) in Chile in 2012?
Provide a short and direct response. -7.69. What is the difference between the Claims(annual growth as % of broad money) of Bulgaria in 2011 and the Claims(annual growth as % of broad money) of Comoros in 2012?
Ensure brevity in your answer.  -6.41. What is the difference between the Claims(annual growth as % of broad money) of Bulgaria in 2011 and the Claims(annual growth as % of broad money) of Morocco in 2012?
Keep it short and to the point. -0.32. What is the difference between the Claims(annual growth as % of broad money) in Chile in 2011 and the Claims(annual growth as % of broad money) in Comoros in 2012?
Your answer should be very brief. 6.13. What is the difference between the Claims(annual growth as % of broad money) of Chile in 2011 and the Claims(annual growth as % of broad money) of Morocco in 2012?
Provide a short and direct response. 12.23. What is the difference between the Claims(annual growth as % of broad money) in Comoros in 2011 and the Claims(annual growth as % of broad money) in Morocco in 2012?
Keep it short and to the point. -1.72. What is the average Claims(annual growth as % of broad money) of Bulgaria per year?
Your answer should be very brief. 15. What is the average Claims(annual growth as % of broad money) of Chile per year?
Ensure brevity in your answer.  11.41. What is the average Claims(annual growth as % of broad money) of Comoros per year?
Provide a short and direct response. 8.71. What is the average Claims(annual growth as % of broad money) in Morocco per year?
Give a very brief answer. 11.57. In the year 2006, what is the difference between the Claims(annual growth as % of broad money) in Bulgaria and Claims(annual growth as % of broad money) in Chile?
Make the answer very short. 4.4. In the year 2006, what is the difference between the Claims(annual growth as % of broad money) of Bulgaria and Claims(annual growth as % of broad money) of Comoros?
Offer a terse response. 17.22. In the year 2006, what is the difference between the Claims(annual growth as % of broad money) of Bulgaria and Claims(annual growth as % of broad money) of Morocco?
Provide a succinct answer. 4.93. In the year 2006, what is the difference between the Claims(annual growth as % of broad money) of Chile and Claims(annual growth as % of broad money) of Comoros?
Provide a succinct answer. 12.82. In the year 2006, what is the difference between the Claims(annual growth as % of broad money) in Chile and Claims(annual growth as % of broad money) in Morocco?
Your response must be concise. 0.53. In the year 2006, what is the difference between the Claims(annual growth as % of broad money) of Comoros and Claims(annual growth as % of broad money) of Morocco?
Your answer should be compact. -12.29. In the year 2007, what is the difference between the Claims(annual growth as % of broad money) of Bulgaria and Claims(annual growth as % of broad money) of Chile?
Ensure brevity in your answer.  27.25. In the year 2007, what is the difference between the Claims(annual growth as % of broad money) in Bulgaria and Claims(annual growth as % of broad money) in Comoros?
Keep it short and to the point. 40.8. In the year 2007, what is the difference between the Claims(annual growth as % of broad money) of Bulgaria and Claims(annual growth as % of broad money) of Morocco?
Provide a succinct answer. 26.88. In the year 2007, what is the difference between the Claims(annual growth as % of broad money) in Chile and Claims(annual growth as % of broad money) in Comoros?
Keep it short and to the point. 13.55. In the year 2007, what is the difference between the Claims(annual growth as % of broad money) in Chile and Claims(annual growth as % of broad money) in Morocco?
Give a very brief answer. -0.37. In the year 2007, what is the difference between the Claims(annual growth as % of broad money) in Comoros and Claims(annual growth as % of broad money) in Morocco?
Provide a succinct answer. -13.92. In the year 2008, what is the difference between the Claims(annual growth as % of broad money) in Bulgaria and Claims(annual growth as % of broad money) in Chile?
Ensure brevity in your answer.  18. In the year 2008, what is the difference between the Claims(annual growth as % of broad money) of Bulgaria and Claims(annual growth as % of broad money) of Comoros?
Offer a terse response. 15.87. In the year 2008, what is the difference between the Claims(annual growth as % of broad money) in Bulgaria and Claims(annual growth as % of broad money) in Morocco?
Offer a terse response. 11.14. In the year 2008, what is the difference between the Claims(annual growth as % of broad money) in Chile and Claims(annual growth as % of broad money) in Comoros?
Make the answer very short. -2.12. In the year 2008, what is the difference between the Claims(annual growth as % of broad money) in Chile and Claims(annual growth as % of broad money) in Morocco?
Give a very brief answer. -6.86. In the year 2008, what is the difference between the Claims(annual growth as % of broad money) in Comoros and Claims(annual growth as % of broad money) in Morocco?
Offer a terse response. -4.74. In the year 2009, what is the difference between the Claims(annual growth as % of broad money) in Bulgaria and Claims(annual growth as % of broad money) in Comoros?
Provide a short and direct response. -10.94. In the year 2009, what is the difference between the Claims(annual growth as % of broad money) of Bulgaria and Claims(annual growth as % of broad money) of Morocco?
Provide a short and direct response. -4.88. In the year 2009, what is the difference between the Claims(annual growth as % of broad money) of Comoros and Claims(annual growth as % of broad money) of Morocco?
Your answer should be compact. 6.06. In the year 2010, what is the difference between the Claims(annual growth as % of broad money) in Bulgaria and Claims(annual growth as % of broad money) in Chile?
Keep it short and to the point. -6.94. In the year 2010, what is the difference between the Claims(annual growth as % of broad money) of Bulgaria and Claims(annual growth as % of broad money) of Comoros?
Provide a succinct answer. -12.45. In the year 2010, what is the difference between the Claims(annual growth as % of broad money) of Bulgaria and Claims(annual growth as % of broad money) of Morocco?
Make the answer very short. -7.5. In the year 2010, what is the difference between the Claims(annual growth as % of broad money) in Chile and Claims(annual growth as % of broad money) in Comoros?
Provide a short and direct response. -5.51. In the year 2010, what is the difference between the Claims(annual growth as % of broad money) in Chile and Claims(annual growth as % of broad money) in Morocco?
Your answer should be compact. -0.56. In the year 2010, what is the difference between the Claims(annual growth as % of broad money) in Comoros and Claims(annual growth as % of broad money) in Morocco?
Make the answer very short. 4.95. In the year 2011, what is the difference between the Claims(annual growth as % of broad money) of Bulgaria and Claims(annual growth as % of broad money) of Chile?
Make the answer very short. -12.55. In the year 2011, what is the difference between the Claims(annual growth as % of broad money) in Bulgaria and Claims(annual growth as % of broad money) in Comoros?
Give a very brief answer. 1.4. In the year 2011, what is the difference between the Claims(annual growth as % of broad money) in Bulgaria and Claims(annual growth as % of broad money) in Morocco?
Your response must be concise. -4.73. In the year 2011, what is the difference between the Claims(annual growth as % of broad money) in Chile and Claims(annual growth as % of broad money) in Comoros?
Give a very brief answer. 13.95. In the year 2011, what is the difference between the Claims(annual growth as % of broad money) in Chile and Claims(annual growth as % of broad money) in Morocco?
Ensure brevity in your answer.  7.82. In the year 2011, what is the difference between the Claims(annual growth as % of broad money) of Comoros and Claims(annual growth as % of broad money) of Morocco?
Your answer should be compact. -6.13. In the year 2012, what is the difference between the Claims(annual growth as % of broad money) of Bulgaria and Claims(annual growth as % of broad money) of Chile?
Provide a succinct answer. -9.18. In the year 2012, what is the difference between the Claims(annual growth as % of broad money) of Bulgaria and Claims(annual growth as % of broad money) of Comoros?
Your answer should be compact. -7.9. In the year 2012, what is the difference between the Claims(annual growth as % of broad money) in Bulgaria and Claims(annual growth as % of broad money) in Morocco?
Ensure brevity in your answer.  -1.81. In the year 2012, what is the difference between the Claims(annual growth as % of broad money) of Chile and Claims(annual growth as % of broad money) of Comoros?
Provide a short and direct response. 1.27. In the year 2012, what is the difference between the Claims(annual growth as % of broad money) of Chile and Claims(annual growth as % of broad money) of Morocco?
Give a very brief answer. 7.37. In the year 2012, what is the difference between the Claims(annual growth as % of broad money) of Comoros and Claims(annual growth as % of broad money) of Morocco?
Give a very brief answer. 6.09. What is the ratio of the Claims(annual growth as % of broad money) in Bulgaria in 2006 to that in 2007?
Offer a very short reply. 0.41. What is the ratio of the Claims(annual growth as % of broad money) of Chile in 2006 to that in 2007?
Your response must be concise. 0.77. What is the ratio of the Claims(annual growth as % of broad money) of Comoros in 2006 to that in 2007?
Ensure brevity in your answer.  0.26. What is the ratio of the Claims(annual growth as % of broad money) in Morocco in 2006 to that in 2007?
Ensure brevity in your answer.  0.72. What is the ratio of the Claims(annual growth as % of broad money) in Bulgaria in 2006 to that in 2008?
Offer a very short reply. 0.65. What is the ratio of the Claims(annual growth as % of broad money) of Chile in 2006 to that in 2008?
Provide a succinct answer. 1.33. What is the ratio of the Claims(annual growth as % of broad money) of Comoros in 2006 to that in 2008?
Provide a short and direct response. 0.1. What is the ratio of the Claims(annual growth as % of broad money) of Morocco in 2006 to that in 2008?
Offer a very short reply. 0.78. What is the ratio of the Claims(annual growth as % of broad money) of Bulgaria in 2006 to that in 2009?
Offer a terse response. 4.48. What is the ratio of the Claims(annual growth as % of broad money) in Comoros in 2006 to that in 2009?
Ensure brevity in your answer.  0.08. What is the ratio of the Claims(annual growth as % of broad money) in Morocco in 2006 to that in 2009?
Give a very brief answer. 1.5. What is the ratio of the Claims(annual growth as % of broad money) of Bulgaria in 2006 to that in 2010?
Your answer should be very brief. 11.98. What is the ratio of the Claims(annual growth as % of broad money) in Chile in 2006 to that in 2010?
Provide a short and direct response. 1.66. What is the ratio of the Claims(annual growth as % of broad money) in Comoros in 2006 to that in 2010?
Provide a short and direct response. 0.09. What is the ratio of the Claims(annual growth as % of broad money) of Morocco in 2006 to that in 2010?
Offer a terse response. 1.5. What is the ratio of the Claims(annual growth as % of broad money) in Bulgaria in 2006 to that in 2011?
Your response must be concise. 4.48. What is the ratio of the Claims(annual growth as % of broad money) of Chile in 2006 to that in 2011?
Your answer should be compact. 0.84. What is the ratio of the Claims(annual growth as % of broad money) of Comoros in 2006 to that in 2011?
Provide a short and direct response. 0.46. What is the ratio of the Claims(annual growth as % of broad money) in Morocco in 2006 to that in 2011?
Give a very brief answer. 1.53. What is the ratio of the Claims(annual growth as % of broad money) of Bulgaria in 2006 to that in 2012?
Your response must be concise. 7.01. What is the ratio of the Claims(annual growth as % of broad money) of Chile in 2006 to that in 2012?
Give a very brief answer. 1.19. What is the ratio of the Claims(annual growth as % of broad money) in Comoros in 2006 to that in 2012?
Offer a terse response. 0.12. What is the ratio of the Claims(annual growth as % of broad money) in Morocco in 2006 to that in 2012?
Provide a succinct answer. 3.05. What is the ratio of the Claims(annual growth as % of broad money) of Bulgaria in 2007 to that in 2008?
Provide a succinct answer. 1.59. What is the ratio of the Claims(annual growth as % of broad money) in Chile in 2007 to that in 2008?
Give a very brief answer. 1.73. What is the ratio of the Claims(annual growth as % of broad money) of Comoros in 2007 to that in 2008?
Offer a terse response. 0.37. What is the ratio of the Claims(annual growth as % of broad money) in Morocco in 2007 to that in 2008?
Make the answer very short. 1.07. What is the ratio of the Claims(annual growth as % of broad money) of Bulgaria in 2007 to that in 2009?
Your answer should be compact. 11.06. What is the ratio of the Claims(annual growth as % of broad money) in Comoros in 2007 to that in 2009?
Offer a terse response. 0.32. What is the ratio of the Claims(annual growth as % of broad money) in Morocco in 2007 to that in 2009?
Offer a very short reply. 2.08. What is the ratio of the Claims(annual growth as % of broad money) of Bulgaria in 2007 to that in 2010?
Keep it short and to the point. 29.57. What is the ratio of the Claims(annual growth as % of broad money) of Chile in 2007 to that in 2010?
Provide a succinct answer. 2.16. What is the ratio of the Claims(annual growth as % of broad money) of Comoros in 2007 to that in 2010?
Your answer should be compact. 0.34. What is the ratio of the Claims(annual growth as % of broad money) of Morocco in 2007 to that in 2010?
Give a very brief answer. 2.07. What is the ratio of the Claims(annual growth as % of broad money) of Bulgaria in 2007 to that in 2011?
Keep it short and to the point. 11.07. What is the ratio of the Claims(annual growth as % of broad money) in Chile in 2007 to that in 2011?
Provide a succinct answer. 1.1. What is the ratio of the Claims(annual growth as % of broad money) of Comoros in 2007 to that in 2011?
Your answer should be compact. 1.75. What is the ratio of the Claims(annual growth as % of broad money) of Morocco in 2007 to that in 2011?
Make the answer very short. 2.11. What is the ratio of the Claims(annual growth as % of broad money) of Bulgaria in 2007 to that in 2012?
Make the answer very short. 17.31. What is the ratio of the Claims(annual growth as % of broad money) in Chile in 2007 to that in 2012?
Your response must be concise. 1.55. What is the ratio of the Claims(annual growth as % of broad money) in Comoros in 2007 to that in 2012?
Provide a succinct answer. 0.45. What is the ratio of the Claims(annual growth as % of broad money) in Morocco in 2007 to that in 2012?
Your answer should be compact. 4.21. What is the ratio of the Claims(annual growth as % of broad money) in Bulgaria in 2008 to that in 2009?
Your answer should be very brief. 6.94. What is the ratio of the Claims(annual growth as % of broad money) of Comoros in 2008 to that in 2009?
Provide a short and direct response. 0.84. What is the ratio of the Claims(annual growth as % of broad money) in Morocco in 2008 to that in 2009?
Keep it short and to the point. 1.94. What is the ratio of the Claims(annual growth as % of broad money) of Bulgaria in 2008 to that in 2010?
Your answer should be compact. 18.55. What is the ratio of the Claims(annual growth as % of broad money) in Chile in 2008 to that in 2010?
Ensure brevity in your answer.  1.25. What is the ratio of the Claims(annual growth as % of broad money) of Comoros in 2008 to that in 2010?
Make the answer very short. 0.91. What is the ratio of the Claims(annual growth as % of broad money) in Morocco in 2008 to that in 2010?
Your answer should be compact. 1.93. What is the ratio of the Claims(annual growth as % of broad money) of Bulgaria in 2008 to that in 2011?
Provide a short and direct response. 6.94. What is the ratio of the Claims(annual growth as % of broad money) in Chile in 2008 to that in 2011?
Offer a terse response. 0.63. What is the ratio of the Claims(annual growth as % of broad money) in Comoros in 2008 to that in 2011?
Your answer should be very brief. 4.67. What is the ratio of the Claims(annual growth as % of broad money) in Morocco in 2008 to that in 2011?
Ensure brevity in your answer.  1.97. What is the ratio of the Claims(annual growth as % of broad money) of Bulgaria in 2008 to that in 2012?
Give a very brief answer. 10.86. What is the ratio of the Claims(annual growth as % of broad money) in Chile in 2008 to that in 2012?
Offer a very short reply. 0.9. What is the ratio of the Claims(annual growth as % of broad money) of Comoros in 2008 to that in 2012?
Ensure brevity in your answer.  1.21. What is the ratio of the Claims(annual growth as % of broad money) in Morocco in 2008 to that in 2012?
Offer a terse response. 3.93. What is the ratio of the Claims(annual growth as % of broad money) in Bulgaria in 2009 to that in 2010?
Your answer should be very brief. 2.67. What is the ratio of the Claims(annual growth as % of broad money) of Comoros in 2009 to that in 2010?
Offer a very short reply. 1.08. What is the ratio of the Claims(annual growth as % of broad money) of Morocco in 2009 to that in 2010?
Offer a terse response. 0.99. What is the ratio of the Claims(annual growth as % of broad money) in Bulgaria in 2009 to that in 2011?
Your answer should be very brief. 1. What is the ratio of the Claims(annual growth as % of broad money) of Comoros in 2009 to that in 2011?
Offer a terse response. 5.54. What is the ratio of the Claims(annual growth as % of broad money) in Morocco in 2009 to that in 2011?
Provide a succinct answer. 1.02. What is the ratio of the Claims(annual growth as % of broad money) in Bulgaria in 2009 to that in 2012?
Give a very brief answer. 1.57. What is the ratio of the Claims(annual growth as % of broad money) of Comoros in 2009 to that in 2012?
Your answer should be compact. 1.43. What is the ratio of the Claims(annual growth as % of broad money) of Morocco in 2009 to that in 2012?
Give a very brief answer. 2.03. What is the ratio of the Claims(annual growth as % of broad money) in Bulgaria in 2010 to that in 2011?
Offer a very short reply. 0.37. What is the ratio of the Claims(annual growth as % of broad money) in Chile in 2010 to that in 2011?
Your answer should be very brief. 0.51. What is the ratio of the Claims(annual growth as % of broad money) in Comoros in 2010 to that in 2011?
Offer a terse response. 5.15. What is the ratio of the Claims(annual growth as % of broad money) of Morocco in 2010 to that in 2011?
Your response must be concise. 1.02. What is the ratio of the Claims(annual growth as % of broad money) of Bulgaria in 2010 to that in 2012?
Offer a very short reply. 0.59. What is the ratio of the Claims(annual growth as % of broad money) in Chile in 2010 to that in 2012?
Your answer should be compact. 0.72. What is the ratio of the Claims(annual growth as % of broad money) in Comoros in 2010 to that in 2012?
Make the answer very short. 1.33. What is the ratio of the Claims(annual growth as % of broad money) of Morocco in 2010 to that in 2012?
Your answer should be compact. 2.04. What is the ratio of the Claims(annual growth as % of broad money) in Bulgaria in 2011 to that in 2012?
Give a very brief answer. 1.56. What is the ratio of the Claims(annual growth as % of broad money) in Chile in 2011 to that in 2012?
Provide a short and direct response. 1.41. What is the ratio of the Claims(annual growth as % of broad money) in Comoros in 2011 to that in 2012?
Your answer should be very brief. 0.26. What is the ratio of the Claims(annual growth as % of broad money) of Morocco in 2011 to that in 2012?
Offer a terse response. 1.99. What is the difference between the highest and the second highest Claims(annual growth as % of broad money) of Bulgaria?
Offer a very short reply. 16.99. What is the difference between the highest and the second highest Claims(annual growth as % of broad money) in Chile?
Your answer should be compact. 1.65. What is the difference between the highest and the second highest Claims(annual growth as % of broad money) of Comoros?
Keep it short and to the point. 1.07. What is the difference between the highest and the second highest Claims(annual growth as % of broad money) of Morocco?
Your response must be concise. 1.24. What is the difference between the highest and the lowest Claims(annual growth as % of broad money) of Bulgaria?
Ensure brevity in your answer.  44.02. What is the difference between the highest and the lowest Claims(annual growth as % of broad money) in Chile?
Offer a terse response. 18.31. What is the difference between the highest and the lowest Claims(annual growth as % of broad money) in Comoros?
Your answer should be compact. 13.82. What is the difference between the highest and the lowest Claims(annual growth as % of broad money) in Morocco?
Your answer should be very brief. 14.24. 